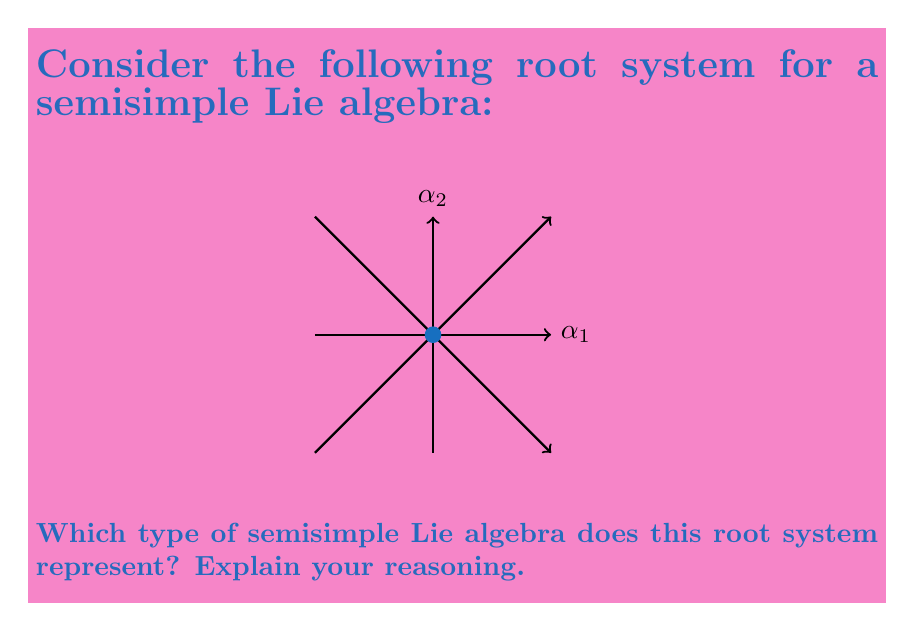Help me with this question. To identify the type of semisimple Lie algebra, we need to analyze the root system:

1. Count the number of simple roots:
   There are two simple roots, $\alpha_1$ and $\alpha_2$.

2. Observe the angle between the simple roots:
   The angle between $\alpha_1$ and $\alpha_2$ is 90°.

3. Check the relative lengths of the simple roots:
   The simple roots $\alpha_1$ and $\alpha_2$ have equal length.

4. Identify the Cartan matrix:
   The Cartan matrix for this root system is:
   $$A = \begin{pmatrix}
   2 & -2 \\
   -2 & 2
   \end{pmatrix}$$

5. Compare with known classifications:
   This root system matches the characteristics of the $A_2$ Lie algebra:
   - Two simple roots
   - 90° angle between simple roots
   - Equal length simple roots
   - Cartan matrix with off-diagonal elements -2

The $A_2$ Lie algebra corresponds to the special linear group $SL(3,\mathbb{C})$ or $SU(3)$ in its compact form.
Answer: $A_2$ 